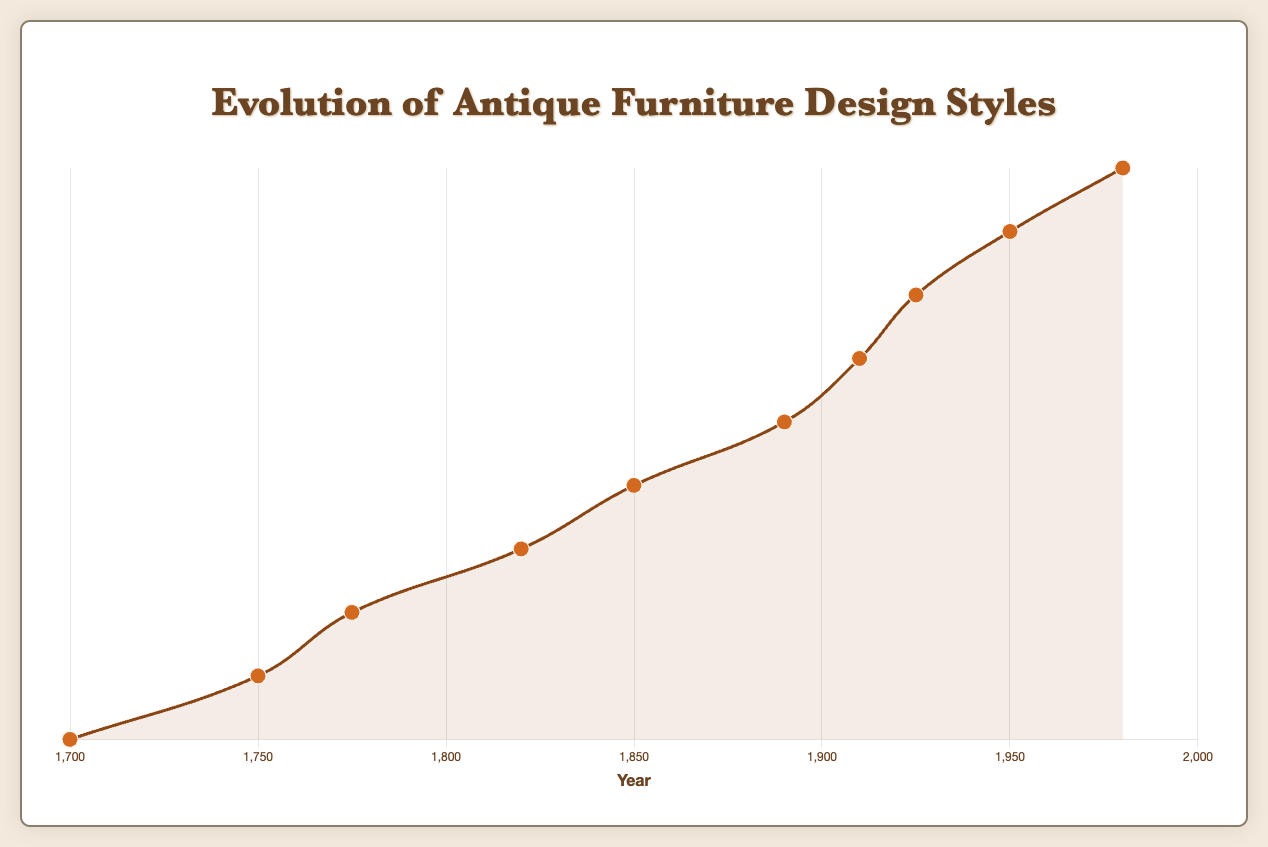What are the distinct design styles listed on the curve? The curve plots the evolution of design styles from 1700 to 1980. Each point on the curve corresponds to a distinct design style. By looking at the labels on the curve: Baroque, Rococo, Neoclassical, Regency, Victorian, Arts and Crafts, Art Nouveau, Art Deco, Mid-Century Modern, Postmodern.
Answer: Baroque, Rococo, Neoclassical, Regency, Victorian, Arts and Crafts, Art Nouveau, Art Deco, Mid-Century Modern, Postmodern Which design style follows directly after Rococo on the timeline? By examining the x-axis labeled with years, Rococo appears at 1750, and the next style following it at 1775 is Neoclassical.
Answer: Neoclassical How many years are there between the introduction of the Regency and the Victorian styles? Locate Regency at 1820 and Victorian at 1850. Subtract 1820 from 1850 to find the difference: 1850 - 1820 = 30 years.
Answer: 30 years Which design style is characterized by "Geometric Shapes" and appears in the 20th century? By examining the tooltip information when hovering over the points at the 20th century, look for "Geometric Shapes" as a characteristic. This is listed under Art Deco, appearing in 1925.
Answer: Art Deco What is the median year of the design styles shown on the curve? To find the median year, we first list all the years (1700, 1750, 1775, 1820, 1850, 1890, 1910, 1925, 1950, 1980). Since there are an even number of data points (10), the median is calculated by averaging the 5th and 6th years. (1850 + 1890) / 2 = 1870.
Answer: 1870 Which design style is represented by the data point with the largest gap from its preceding style on the graph? Identify the gaps between consecutive years on the timeline. The largest gap is between 1700 and 1750, a 50-year difference, with Rococo following Baroque.
Answer: Rococo Comparing the styles Art Nouveau and Postmodern, which one appears first on the curve? Art Nouveau is shown at 1910 and Postmodern at 1980. By the years, Art Nouveau comes first.
Answer: Art Nouveau What material is popular in both Baroque and Victorian design styles? By examining the tooltip for both Baroque and Victorian data points, "Walnut" appears as a popular material in both styles.
Answer: Walnut 